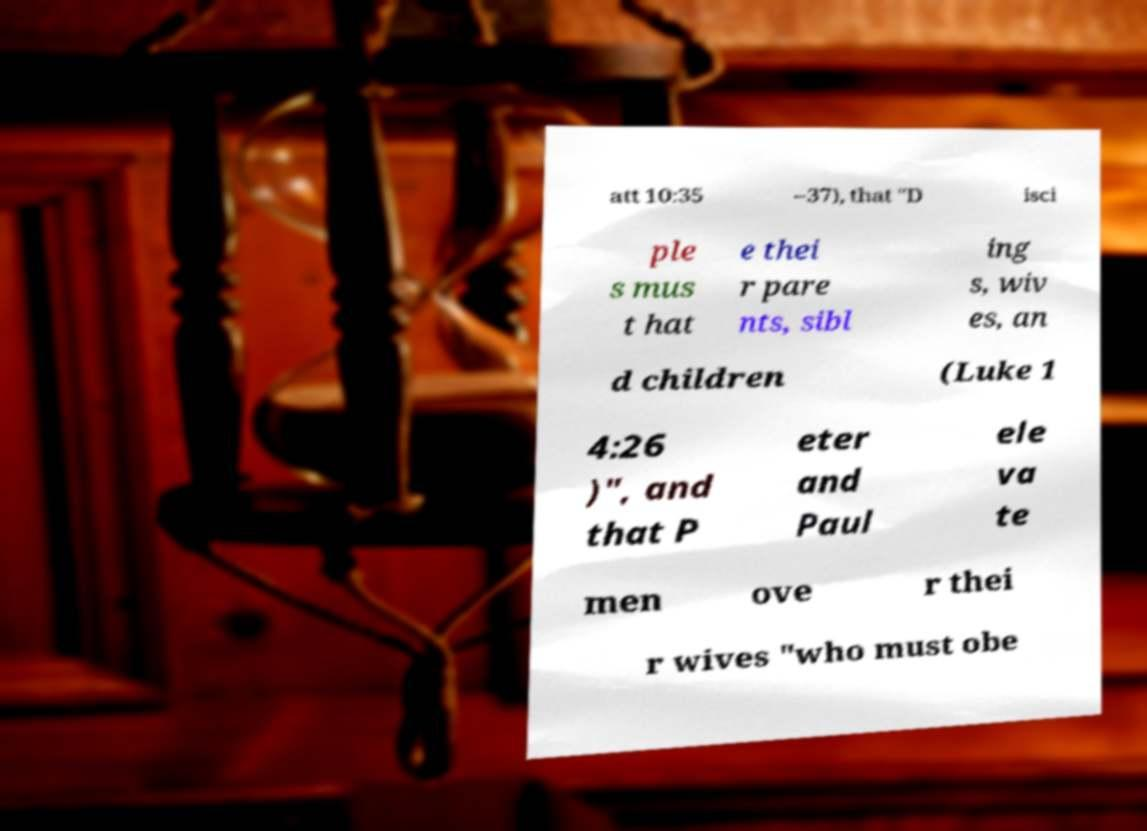There's text embedded in this image that I need extracted. Can you transcribe it verbatim? att 10:35 –37), that "D isci ple s mus t hat e thei r pare nts, sibl ing s, wiv es, an d children (Luke 1 4:26 )", and that P eter and Paul ele va te men ove r thei r wives "who must obe 